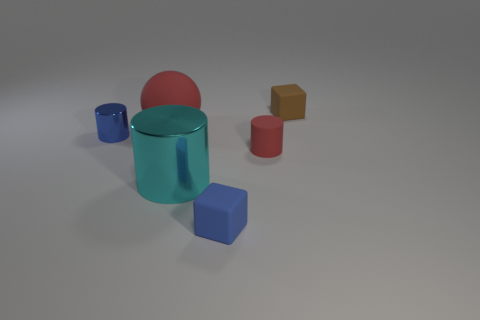Add 2 small blue shiny cylinders. How many objects exist? 8 Subtract all blocks. How many objects are left? 4 Subtract 0 brown cylinders. How many objects are left? 6 Subtract all large matte objects. Subtract all big metallic things. How many objects are left? 4 Add 1 rubber things. How many rubber things are left? 5 Add 4 blue shiny objects. How many blue shiny objects exist? 5 